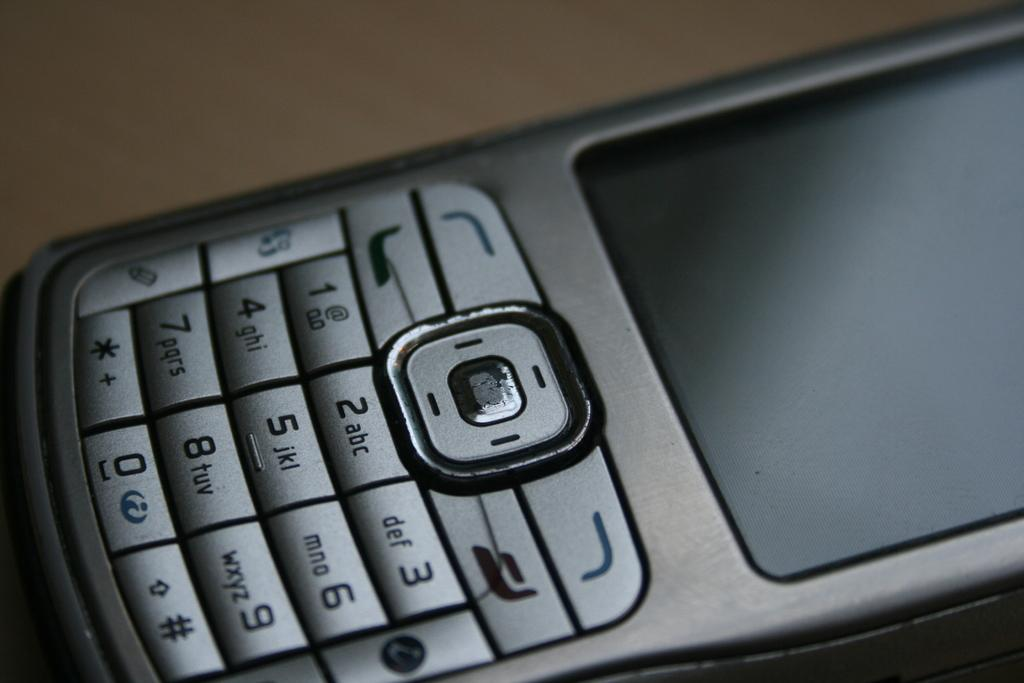Provide a one-sentence caption for the provided image. The numbers 1-9 and zero are shown on a cell phone. 